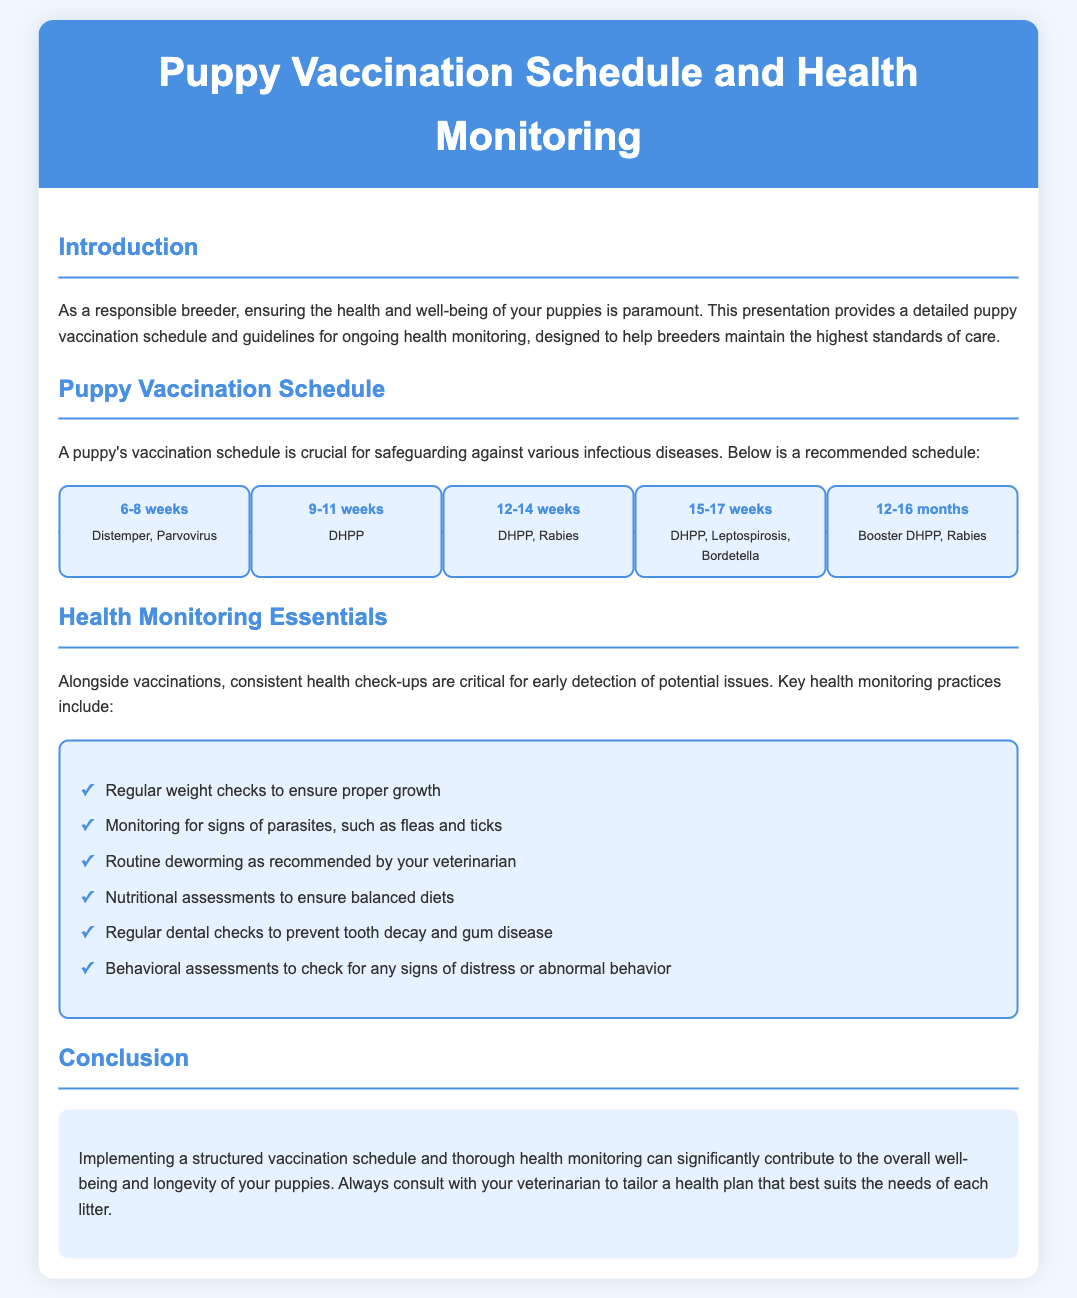What is the main purpose of the presentation? The presentation aims to provide a detailed puppy vaccination schedule and guidelines for ongoing health monitoring to help breeders maintain high standards of care.
Answer: Maintaining high standards of care What vaccination is given at 6-8 weeks? The timeline specifies that Distemper and Parvovirus vaccinations are given at this age.
Answer: Distemper, Parvovirus At what age should the first DHPP vaccine be administered? The timeline indicates that the first DHPP vaccine should be administered at 9-11 weeks.
Answer: 9-11 weeks How many key health monitoring practices are listed? The checklist outlines a total of six key health monitoring practices.
Answer: Six What should be monitored to ensure balanced diets? One of the health monitoring practices focuses on conducting nutritional assessments.
Answer: Nutritional assessments What is the time frame for the booster vaccines? The timeline indicates that booster vaccines for DHPP and Rabies are given between 12-16 months.
Answer: 12-16 months Which health issue is specifically mentioned to be checked for during health monitoring? The checklist specifically states that monitoring for signs of parasites is essential.
Answer: Parasites What color is used for the timeline items? The timeline items are styled with a background color of light blue.
Answer: Light blue Which section contains a checklist? The section titled "Health Monitoring Essentials" contains the checklist.
Answer: Health Monitoring Essentials 